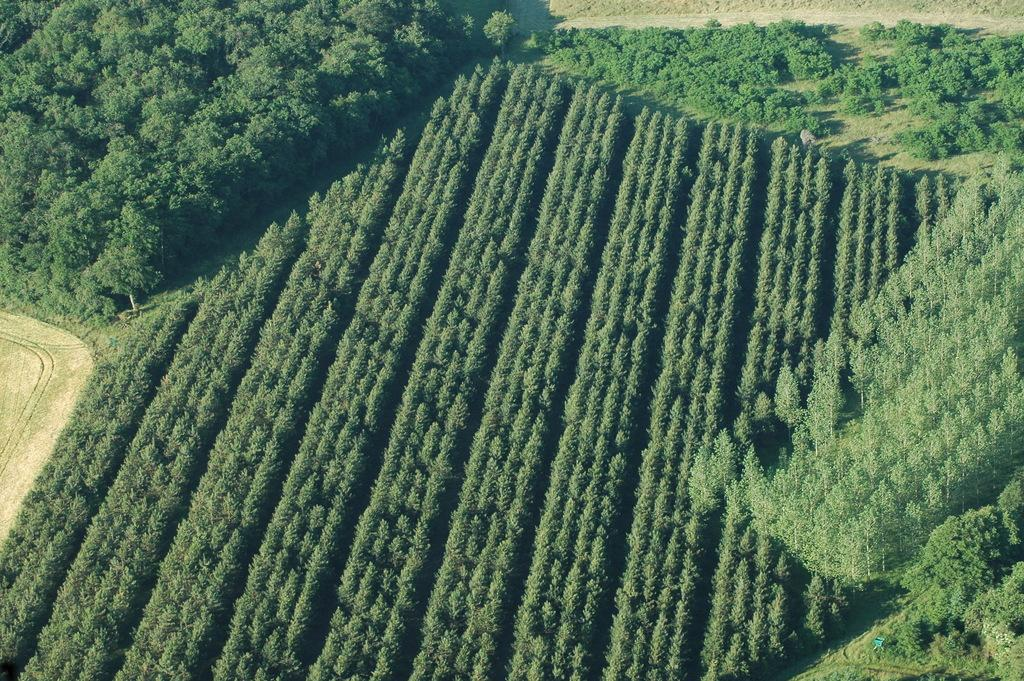What type of vegetation covers the land in the image? The land in the image is covered with trees. Can you describe the terrain in the image? The terrain in the image is covered with trees, indicating a forest or wooded area. What might be the climate or environment in the area depicted in the image? The presence of trees suggests a temperate or forested environment, which could indicate a moderate climate. What type of station can be seen in the image? There is no station present in the image; it only shows land covered with trees. 